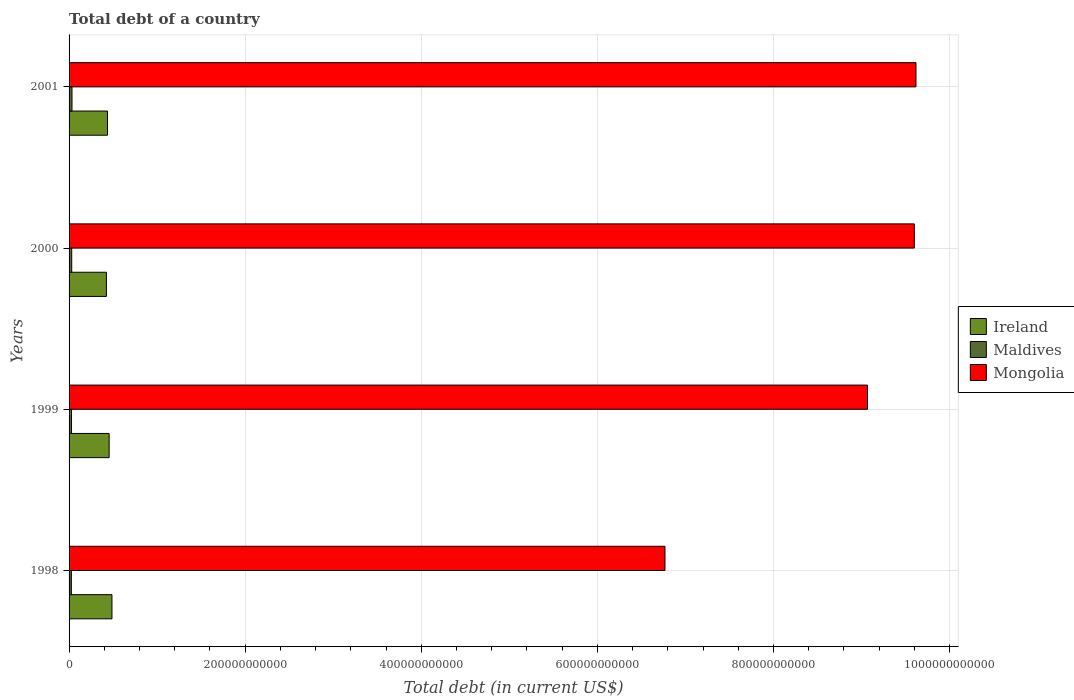How many different coloured bars are there?
Your answer should be very brief. 3. Are the number of bars on each tick of the Y-axis equal?
Your answer should be compact. Yes. How many bars are there on the 1st tick from the top?
Ensure brevity in your answer.  3. What is the debt in Mongolia in 1998?
Your answer should be very brief. 6.77e+11. Across all years, what is the maximum debt in Maldives?
Provide a succinct answer. 3.33e+09. Across all years, what is the minimum debt in Maldives?
Provide a short and direct response. 2.61e+09. What is the total debt in Maldives in the graph?
Give a very brief answer. 1.17e+1. What is the difference between the debt in Mongolia in 1999 and that in 2000?
Your response must be concise. -5.32e+1. What is the difference between the debt in Mongolia in 1998 and the debt in Maldives in 2001?
Provide a short and direct response. 6.73e+11. What is the average debt in Ireland per year?
Provide a short and direct response. 4.51e+1. In the year 1999, what is the difference between the debt in Mongolia and debt in Ireland?
Your response must be concise. 8.61e+11. In how many years, is the debt in Ireland greater than 680000000000 US$?
Provide a succinct answer. 0. What is the ratio of the debt in Mongolia in 1998 to that in 2001?
Your answer should be very brief. 0.7. Is the debt in Maldives in 1998 less than that in 2000?
Your answer should be compact. Yes. What is the difference between the highest and the second highest debt in Mongolia?
Offer a terse response. 1.90e+09. What is the difference between the highest and the lowest debt in Ireland?
Provide a succinct answer. 6.29e+09. What does the 1st bar from the top in 2000 represents?
Provide a succinct answer. Mongolia. What does the 2nd bar from the bottom in 2001 represents?
Make the answer very short. Maldives. How many bars are there?
Your answer should be very brief. 12. How many years are there in the graph?
Make the answer very short. 4. What is the difference between two consecutive major ticks on the X-axis?
Keep it short and to the point. 2.00e+11. Are the values on the major ticks of X-axis written in scientific E-notation?
Offer a very short reply. No. How many legend labels are there?
Make the answer very short. 3. How are the legend labels stacked?
Make the answer very short. Vertical. What is the title of the graph?
Provide a succinct answer. Total debt of a country. Does "Gambia, The" appear as one of the legend labels in the graph?
Offer a terse response. No. What is the label or title of the X-axis?
Ensure brevity in your answer.  Total debt (in current US$). What is the Total debt (in current US$) of Ireland in 1998?
Give a very brief answer. 4.87e+1. What is the Total debt (in current US$) in Maldives in 1998?
Your response must be concise. 2.61e+09. What is the Total debt (in current US$) in Mongolia in 1998?
Provide a succinct answer. 6.77e+11. What is the Total debt (in current US$) in Ireland in 1999?
Give a very brief answer. 4.55e+1. What is the Total debt (in current US$) of Maldives in 1999?
Make the answer very short. 2.78e+09. What is the Total debt (in current US$) of Mongolia in 1999?
Your answer should be very brief. 9.07e+11. What is the Total debt (in current US$) of Ireland in 2000?
Offer a terse response. 4.24e+1. What is the Total debt (in current US$) in Maldives in 2000?
Offer a very short reply. 3.00e+09. What is the Total debt (in current US$) in Mongolia in 2000?
Your answer should be very brief. 9.60e+11. What is the Total debt (in current US$) in Ireland in 2001?
Offer a terse response. 4.37e+1. What is the Total debt (in current US$) of Maldives in 2001?
Your answer should be very brief. 3.33e+09. What is the Total debt (in current US$) of Mongolia in 2001?
Keep it short and to the point. 9.62e+11. Across all years, what is the maximum Total debt (in current US$) of Ireland?
Offer a very short reply. 4.87e+1. Across all years, what is the maximum Total debt (in current US$) of Maldives?
Your answer should be very brief. 3.33e+09. Across all years, what is the maximum Total debt (in current US$) in Mongolia?
Provide a short and direct response. 9.62e+11. Across all years, what is the minimum Total debt (in current US$) of Ireland?
Your response must be concise. 4.24e+1. Across all years, what is the minimum Total debt (in current US$) of Maldives?
Offer a very short reply. 2.61e+09. Across all years, what is the minimum Total debt (in current US$) of Mongolia?
Ensure brevity in your answer.  6.77e+11. What is the total Total debt (in current US$) in Ireland in the graph?
Provide a short and direct response. 1.80e+11. What is the total Total debt (in current US$) of Maldives in the graph?
Your answer should be very brief. 1.17e+1. What is the total Total debt (in current US$) of Mongolia in the graph?
Provide a short and direct response. 3.51e+12. What is the difference between the Total debt (in current US$) of Ireland in 1998 and that in 1999?
Ensure brevity in your answer.  3.19e+09. What is the difference between the Total debt (in current US$) in Maldives in 1998 and that in 1999?
Make the answer very short. -1.77e+08. What is the difference between the Total debt (in current US$) in Mongolia in 1998 and that in 1999?
Make the answer very short. -2.30e+11. What is the difference between the Total debt (in current US$) of Ireland in 1998 and that in 2000?
Ensure brevity in your answer.  6.29e+09. What is the difference between the Total debt (in current US$) of Maldives in 1998 and that in 2000?
Your answer should be very brief. -3.97e+08. What is the difference between the Total debt (in current US$) in Mongolia in 1998 and that in 2000?
Keep it short and to the point. -2.83e+11. What is the difference between the Total debt (in current US$) in Ireland in 1998 and that in 2001?
Keep it short and to the point. 5.04e+09. What is the difference between the Total debt (in current US$) in Maldives in 1998 and that in 2001?
Your answer should be compact. -7.21e+08. What is the difference between the Total debt (in current US$) of Mongolia in 1998 and that in 2001?
Keep it short and to the point. -2.85e+11. What is the difference between the Total debt (in current US$) of Ireland in 1999 and that in 2000?
Your answer should be very brief. 3.09e+09. What is the difference between the Total debt (in current US$) of Maldives in 1999 and that in 2000?
Give a very brief answer. -2.20e+08. What is the difference between the Total debt (in current US$) of Mongolia in 1999 and that in 2000?
Give a very brief answer. -5.32e+1. What is the difference between the Total debt (in current US$) of Ireland in 1999 and that in 2001?
Offer a very short reply. 1.84e+09. What is the difference between the Total debt (in current US$) of Maldives in 1999 and that in 2001?
Make the answer very short. -5.44e+08. What is the difference between the Total debt (in current US$) of Mongolia in 1999 and that in 2001?
Your response must be concise. -5.51e+1. What is the difference between the Total debt (in current US$) in Ireland in 2000 and that in 2001?
Your response must be concise. -1.25e+09. What is the difference between the Total debt (in current US$) in Maldives in 2000 and that in 2001?
Provide a short and direct response. -3.24e+08. What is the difference between the Total debt (in current US$) in Mongolia in 2000 and that in 2001?
Your answer should be very brief. -1.90e+09. What is the difference between the Total debt (in current US$) in Ireland in 1998 and the Total debt (in current US$) in Maldives in 1999?
Your answer should be compact. 4.59e+1. What is the difference between the Total debt (in current US$) of Ireland in 1998 and the Total debt (in current US$) of Mongolia in 1999?
Your response must be concise. -8.58e+11. What is the difference between the Total debt (in current US$) in Maldives in 1998 and the Total debt (in current US$) in Mongolia in 1999?
Keep it short and to the point. -9.04e+11. What is the difference between the Total debt (in current US$) in Ireland in 1998 and the Total debt (in current US$) in Maldives in 2000?
Your response must be concise. 4.57e+1. What is the difference between the Total debt (in current US$) in Ireland in 1998 and the Total debt (in current US$) in Mongolia in 2000?
Your response must be concise. -9.11e+11. What is the difference between the Total debt (in current US$) in Maldives in 1998 and the Total debt (in current US$) in Mongolia in 2000?
Keep it short and to the point. -9.57e+11. What is the difference between the Total debt (in current US$) of Ireland in 1998 and the Total debt (in current US$) of Maldives in 2001?
Your response must be concise. 4.54e+1. What is the difference between the Total debt (in current US$) of Ireland in 1998 and the Total debt (in current US$) of Mongolia in 2001?
Your answer should be compact. -9.13e+11. What is the difference between the Total debt (in current US$) of Maldives in 1998 and the Total debt (in current US$) of Mongolia in 2001?
Your answer should be very brief. -9.59e+11. What is the difference between the Total debt (in current US$) of Ireland in 1999 and the Total debt (in current US$) of Maldives in 2000?
Offer a terse response. 4.25e+1. What is the difference between the Total debt (in current US$) in Ireland in 1999 and the Total debt (in current US$) in Mongolia in 2000?
Your answer should be very brief. -9.14e+11. What is the difference between the Total debt (in current US$) in Maldives in 1999 and the Total debt (in current US$) in Mongolia in 2000?
Your answer should be very brief. -9.57e+11. What is the difference between the Total debt (in current US$) of Ireland in 1999 and the Total debt (in current US$) of Maldives in 2001?
Ensure brevity in your answer.  4.22e+1. What is the difference between the Total debt (in current US$) in Ireland in 1999 and the Total debt (in current US$) in Mongolia in 2001?
Offer a terse response. -9.16e+11. What is the difference between the Total debt (in current US$) in Maldives in 1999 and the Total debt (in current US$) in Mongolia in 2001?
Keep it short and to the point. -9.59e+11. What is the difference between the Total debt (in current US$) of Ireland in 2000 and the Total debt (in current US$) of Maldives in 2001?
Give a very brief answer. 3.91e+1. What is the difference between the Total debt (in current US$) in Ireland in 2000 and the Total debt (in current US$) in Mongolia in 2001?
Offer a terse response. -9.19e+11. What is the difference between the Total debt (in current US$) in Maldives in 2000 and the Total debt (in current US$) in Mongolia in 2001?
Ensure brevity in your answer.  -9.59e+11. What is the average Total debt (in current US$) in Ireland per year?
Your answer should be very brief. 4.51e+1. What is the average Total debt (in current US$) in Maldives per year?
Offer a very short reply. 2.93e+09. What is the average Total debt (in current US$) in Mongolia per year?
Give a very brief answer. 8.76e+11. In the year 1998, what is the difference between the Total debt (in current US$) of Ireland and Total debt (in current US$) of Maldives?
Give a very brief answer. 4.61e+1. In the year 1998, what is the difference between the Total debt (in current US$) in Ireland and Total debt (in current US$) in Mongolia?
Offer a very short reply. -6.28e+11. In the year 1998, what is the difference between the Total debt (in current US$) in Maldives and Total debt (in current US$) in Mongolia?
Your response must be concise. -6.74e+11. In the year 1999, what is the difference between the Total debt (in current US$) of Ireland and Total debt (in current US$) of Maldives?
Keep it short and to the point. 4.27e+1. In the year 1999, what is the difference between the Total debt (in current US$) of Ireland and Total debt (in current US$) of Mongolia?
Provide a succinct answer. -8.61e+11. In the year 1999, what is the difference between the Total debt (in current US$) of Maldives and Total debt (in current US$) of Mongolia?
Your answer should be compact. -9.04e+11. In the year 2000, what is the difference between the Total debt (in current US$) of Ireland and Total debt (in current US$) of Maldives?
Ensure brevity in your answer.  3.94e+1. In the year 2000, what is the difference between the Total debt (in current US$) of Ireland and Total debt (in current US$) of Mongolia?
Provide a succinct answer. -9.17e+11. In the year 2000, what is the difference between the Total debt (in current US$) in Maldives and Total debt (in current US$) in Mongolia?
Provide a short and direct response. -9.57e+11. In the year 2001, what is the difference between the Total debt (in current US$) of Ireland and Total debt (in current US$) of Maldives?
Your response must be concise. 4.03e+1. In the year 2001, what is the difference between the Total debt (in current US$) of Ireland and Total debt (in current US$) of Mongolia?
Provide a succinct answer. -9.18e+11. In the year 2001, what is the difference between the Total debt (in current US$) in Maldives and Total debt (in current US$) in Mongolia?
Offer a terse response. -9.58e+11. What is the ratio of the Total debt (in current US$) in Ireland in 1998 to that in 1999?
Make the answer very short. 1.07. What is the ratio of the Total debt (in current US$) in Maldives in 1998 to that in 1999?
Ensure brevity in your answer.  0.94. What is the ratio of the Total debt (in current US$) in Mongolia in 1998 to that in 1999?
Provide a succinct answer. 0.75. What is the ratio of the Total debt (in current US$) in Ireland in 1998 to that in 2000?
Your answer should be compact. 1.15. What is the ratio of the Total debt (in current US$) in Maldives in 1998 to that in 2000?
Offer a terse response. 0.87. What is the ratio of the Total debt (in current US$) of Mongolia in 1998 to that in 2000?
Offer a terse response. 0.7. What is the ratio of the Total debt (in current US$) in Ireland in 1998 to that in 2001?
Provide a short and direct response. 1.12. What is the ratio of the Total debt (in current US$) in Maldives in 1998 to that in 2001?
Provide a short and direct response. 0.78. What is the ratio of the Total debt (in current US$) of Mongolia in 1998 to that in 2001?
Offer a terse response. 0.7. What is the ratio of the Total debt (in current US$) in Ireland in 1999 to that in 2000?
Make the answer very short. 1.07. What is the ratio of the Total debt (in current US$) in Maldives in 1999 to that in 2000?
Make the answer very short. 0.93. What is the ratio of the Total debt (in current US$) of Mongolia in 1999 to that in 2000?
Your response must be concise. 0.94. What is the ratio of the Total debt (in current US$) in Ireland in 1999 to that in 2001?
Your answer should be very brief. 1.04. What is the ratio of the Total debt (in current US$) in Maldives in 1999 to that in 2001?
Offer a very short reply. 0.84. What is the ratio of the Total debt (in current US$) in Mongolia in 1999 to that in 2001?
Your answer should be very brief. 0.94. What is the ratio of the Total debt (in current US$) of Ireland in 2000 to that in 2001?
Provide a short and direct response. 0.97. What is the ratio of the Total debt (in current US$) in Maldives in 2000 to that in 2001?
Offer a very short reply. 0.9. What is the ratio of the Total debt (in current US$) of Mongolia in 2000 to that in 2001?
Offer a terse response. 1. What is the difference between the highest and the second highest Total debt (in current US$) in Ireland?
Your answer should be very brief. 3.19e+09. What is the difference between the highest and the second highest Total debt (in current US$) in Maldives?
Keep it short and to the point. 3.24e+08. What is the difference between the highest and the second highest Total debt (in current US$) in Mongolia?
Ensure brevity in your answer.  1.90e+09. What is the difference between the highest and the lowest Total debt (in current US$) in Ireland?
Your answer should be compact. 6.29e+09. What is the difference between the highest and the lowest Total debt (in current US$) of Maldives?
Ensure brevity in your answer.  7.21e+08. What is the difference between the highest and the lowest Total debt (in current US$) in Mongolia?
Provide a succinct answer. 2.85e+11. 